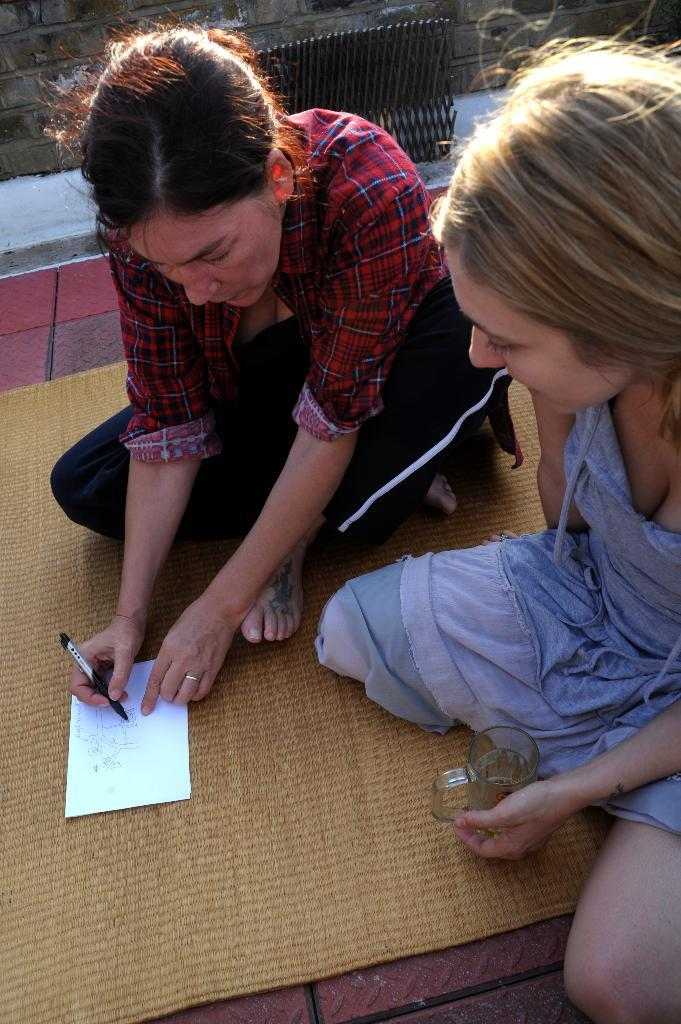How many people are in the image? There are two girls in the image. What can be said about the appearance of the girls? The girls are beautiful. What are the girls doing in the image? The girls are sitting and looking at a paper. What type of ant can be seen supporting the paper in the image? There are no ants present in the image, and the paper is not being supported by any insects. 